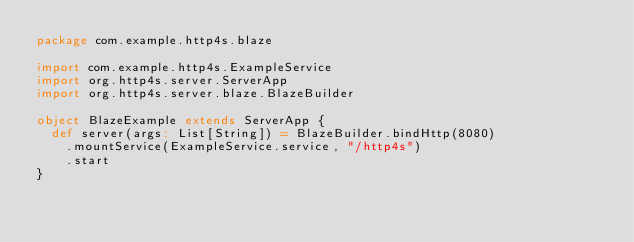Convert code to text. <code><loc_0><loc_0><loc_500><loc_500><_Scala_>package com.example.http4s.blaze

import com.example.http4s.ExampleService
import org.http4s.server.ServerApp
import org.http4s.server.blaze.BlazeBuilder

object BlazeExample extends ServerApp {
  def server(args: List[String]) = BlazeBuilder.bindHttp(8080)
    .mountService(ExampleService.service, "/http4s")
    .start
}
</code> 